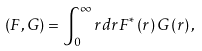Convert formula to latex. <formula><loc_0><loc_0><loc_500><loc_500>\left ( F , G \right ) = \int _ { 0 } ^ { \infty } r d r F ^ { * } \left ( r \right ) G \left ( r \right ) ,</formula> 